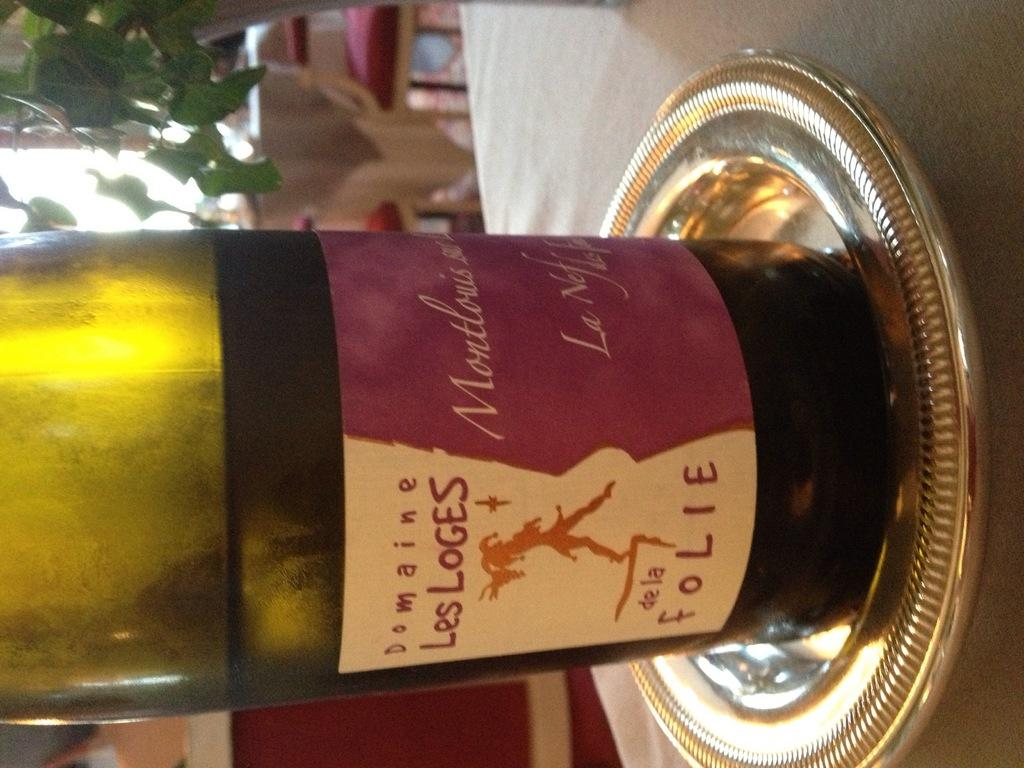What is on the table in the image? There is a liquor bottle on the table in the image. How is the liquor bottle positioned on the table? The liquor bottle is on a plate. What type of plant can be seen in the image? There is a house plant visible in the image. Where was the image taken? The image was taken inside a shop. How much debt does the bucket owe to the liquor bottle in the image? There is no bucket present in the image, so it is not possible to determine any debt owed. 